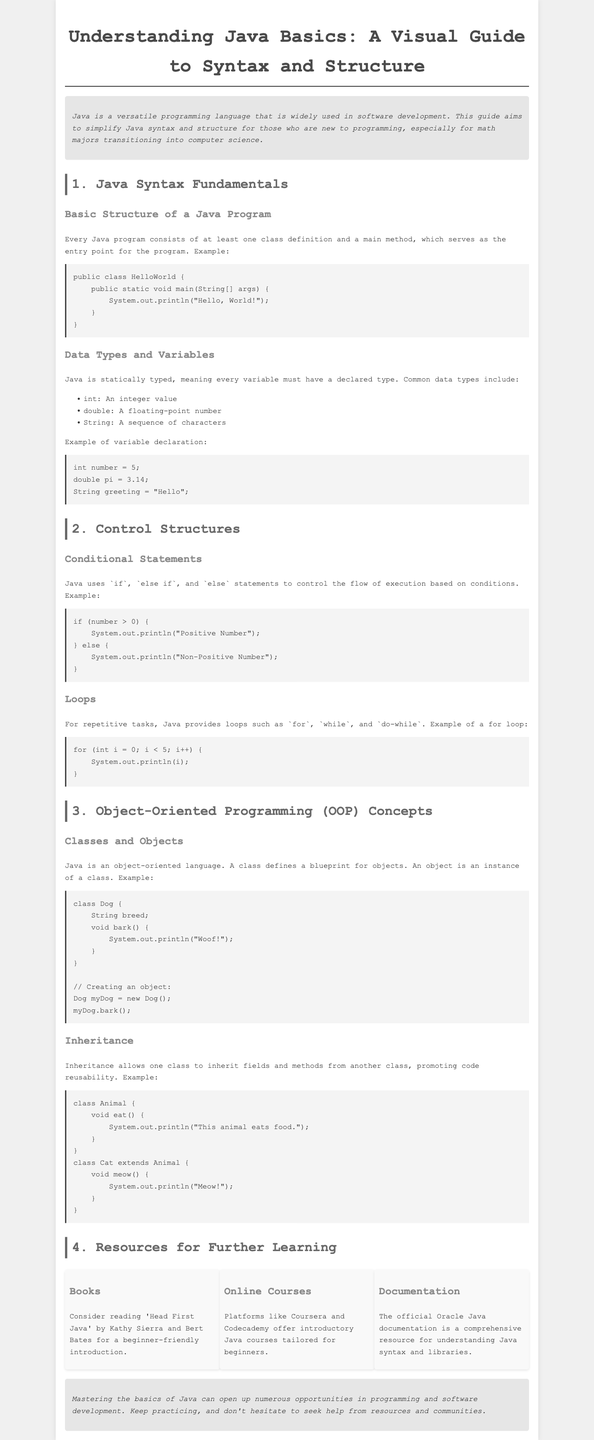What is the main purpose of the guide? The main purpose of the guide is to simplify Java syntax and structure for those who are new to programming.
Answer: simplify Java syntax and structure What is a common data type in Java? The document lists common data types, one of which is "String".
Answer: String What keyword is used to define a class in Java? The document illustrates the class definition with the keyword "public".
Answer: public What is the output of the given "HelloWorld" program? The program example prints "Hello, World!" to the console.
Answer: Hello, World! What are the three types of loops mentioned in the document? The document mentions "for", "while", and "do-while" loops.
Answer: for, while, do-while How does the inheritance feature in Java work? The document explains inheritance, stating that one class can inherit fields and methods from another class.
Answer: inherits fields and methods What is one resource for further learning mentioned in the brochure? The brochure lists "Head First Java" by Kathy Sierra and Bert Bates as a resource.
Answer: Head First Java What does the class "Dog" do when the method bark is called? The class "Dog" prints "Woof!" when the bark method is called.
Answer: Woof! How many sections are there in the guide? The guide is organized into four sections.
Answer: four 